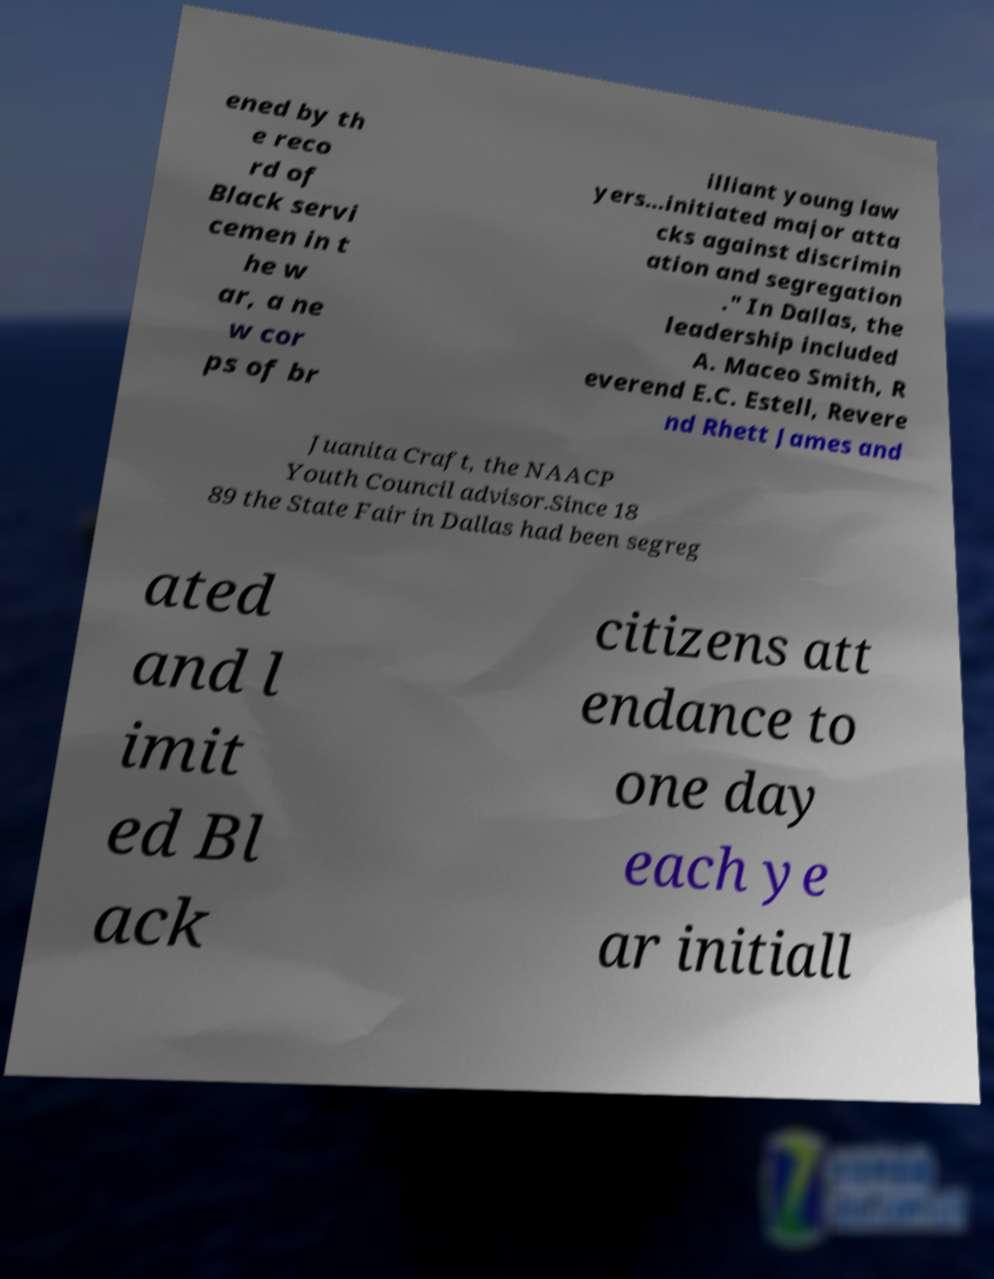Please read and relay the text visible in this image. What does it say? ened by th e reco rd of Black servi cemen in t he w ar, a ne w cor ps of br illiant young law yers…initiated major atta cks against discrimin ation and segregation ." In Dallas, the leadership included A. Maceo Smith, R everend E.C. Estell, Revere nd Rhett James and Juanita Craft, the NAACP Youth Council advisor.Since 18 89 the State Fair in Dallas had been segreg ated and l imit ed Bl ack citizens att endance to one day each ye ar initiall 